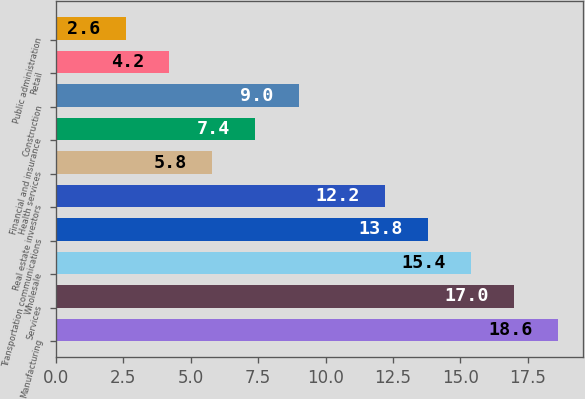<chart> <loc_0><loc_0><loc_500><loc_500><bar_chart><fcel>Manufacturing<fcel>Services<fcel>Wholesale<fcel>Transportation communications<fcel>Real estate investors<fcel>Health services<fcel>Financial and insurance<fcel>Construction<fcel>Retail<fcel>Public administration<nl><fcel>18.6<fcel>17<fcel>15.4<fcel>13.8<fcel>12.2<fcel>5.8<fcel>7.4<fcel>9<fcel>4.2<fcel>2.6<nl></chart> 